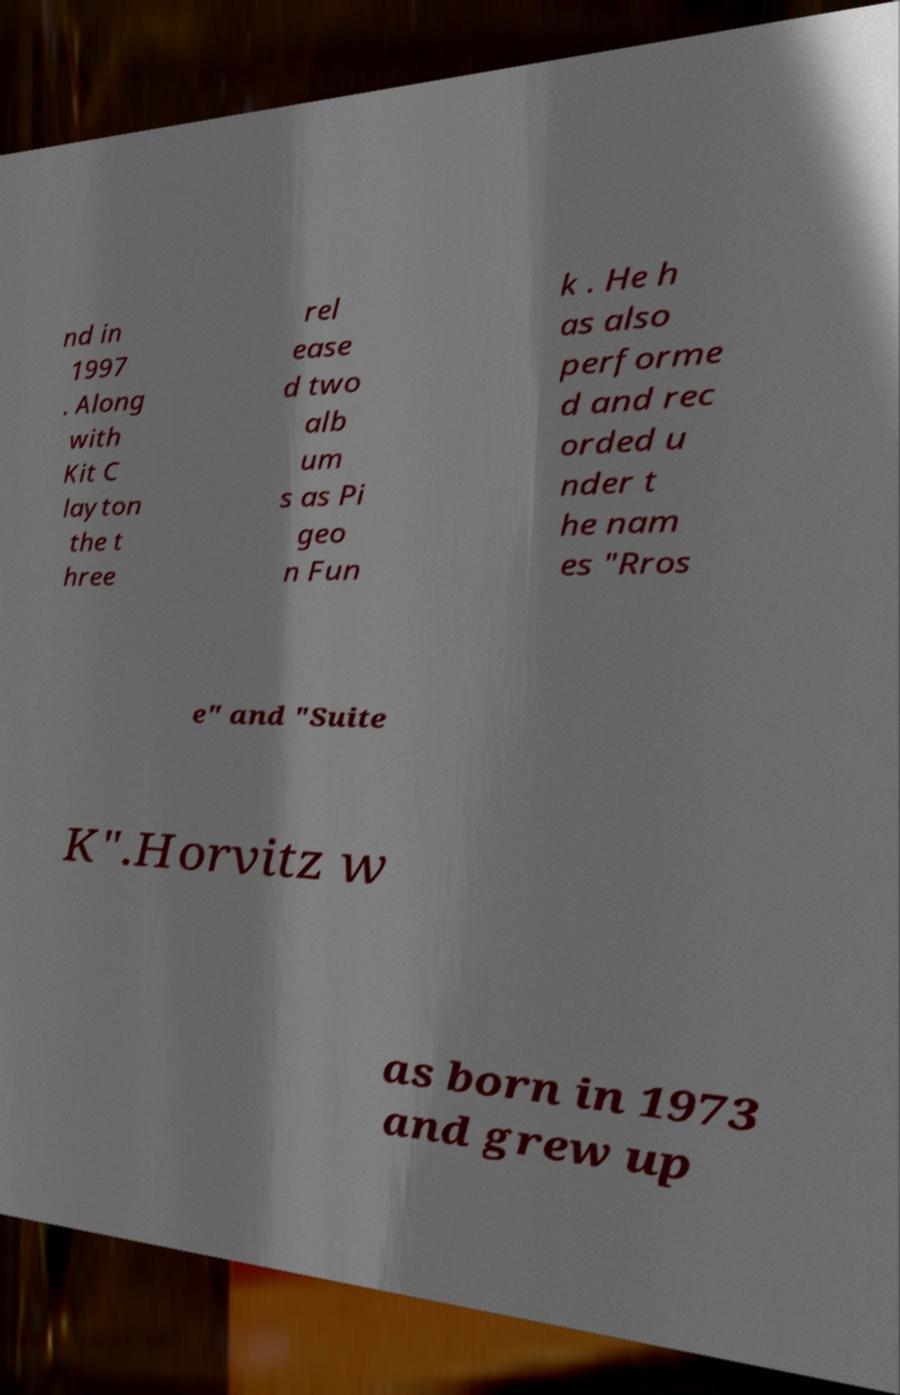There's text embedded in this image that I need extracted. Can you transcribe it verbatim? nd in 1997 . Along with Kit C layton the t hree rel ease d two alb um s as Pi geo n Fun k . He h as also performe d and rec orded u nder t he nam es "Rros e" and "Suite K".Horvitz w as born in 1973 and grew up 